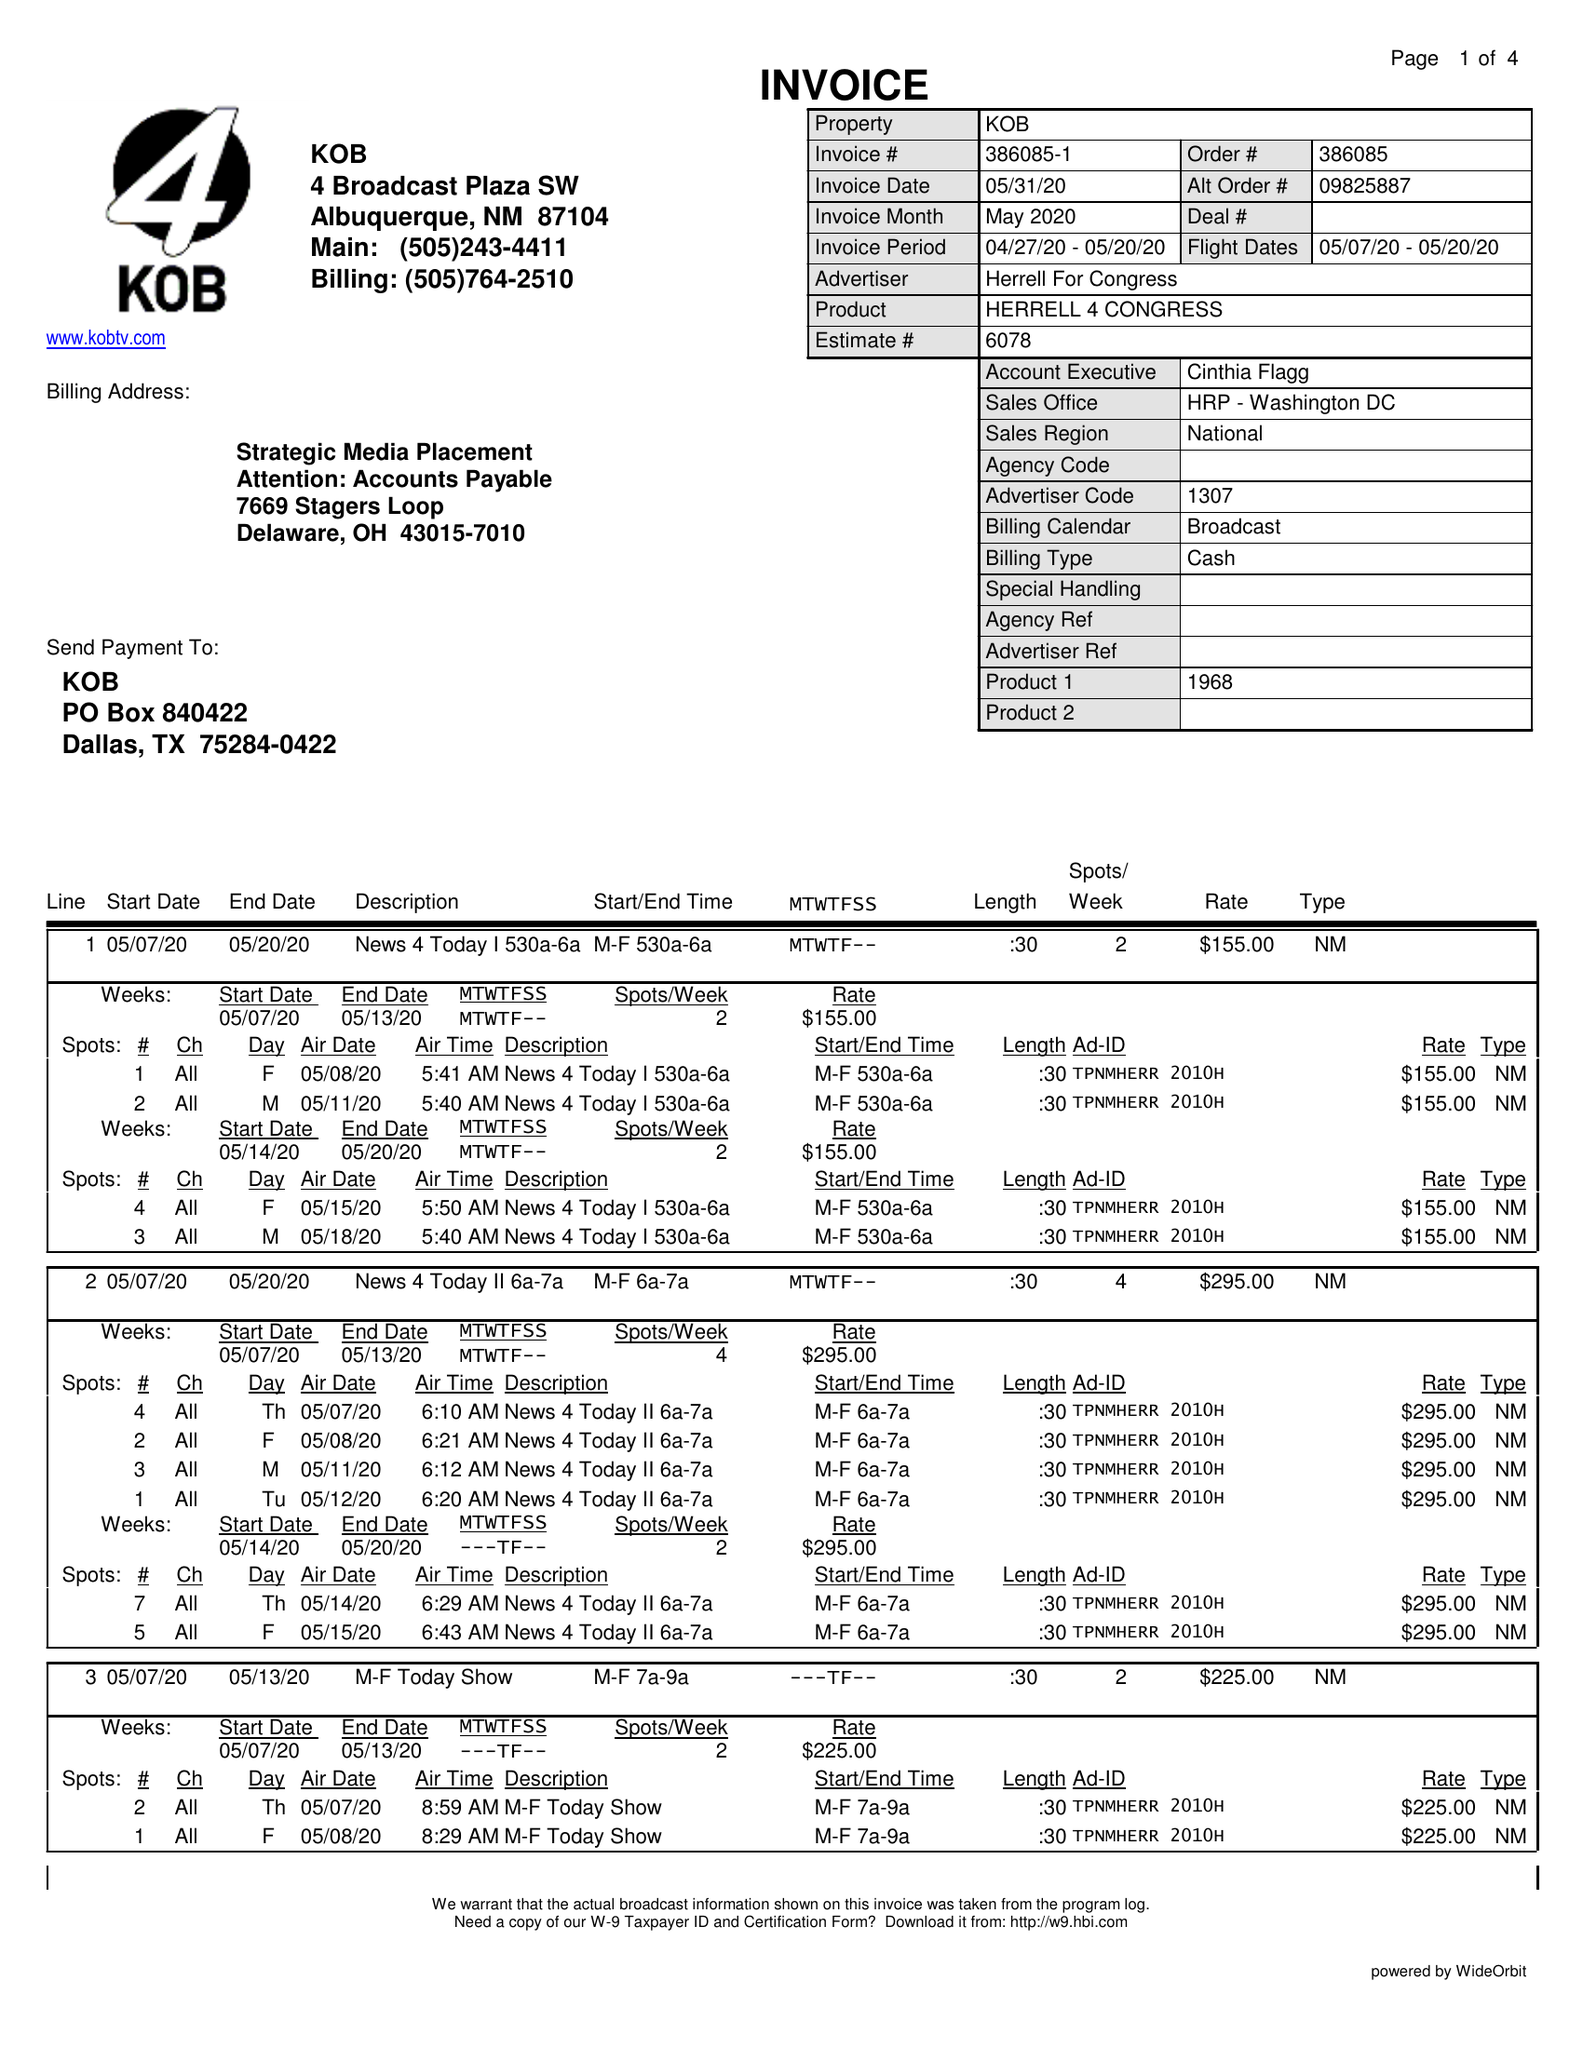What is the value for the contract_num?
Answer the question using a single word or phrase. 386085 